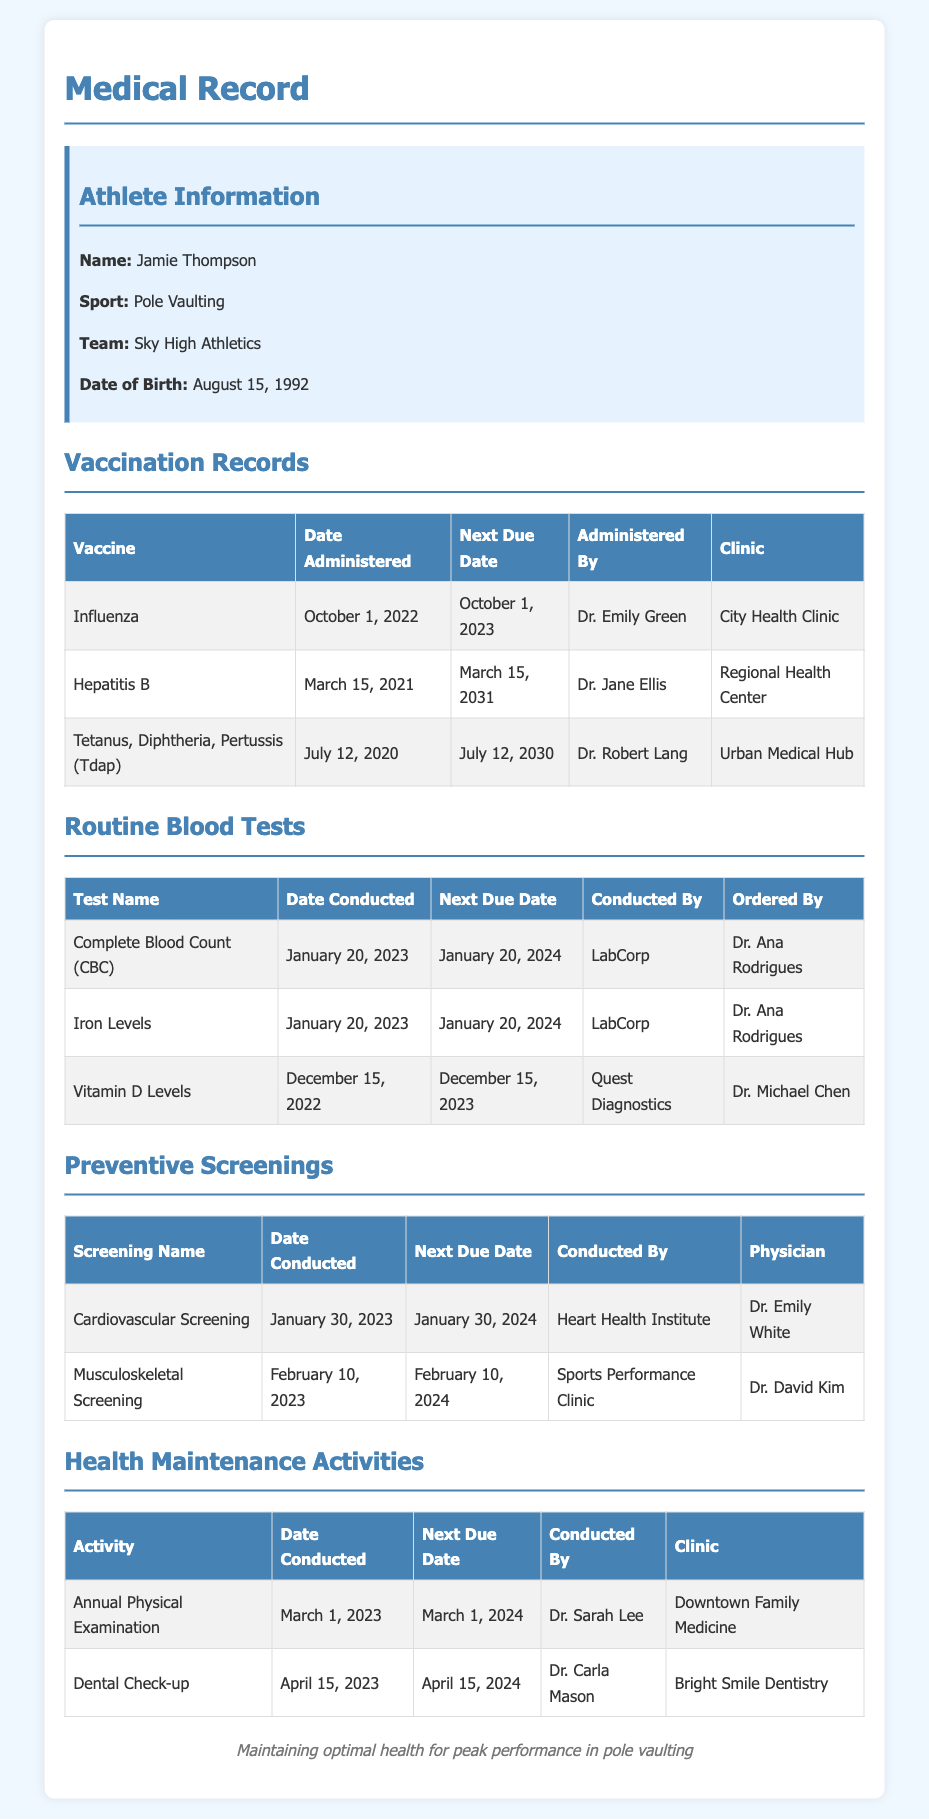What is the athlete's name? The athlete's name is listed in the document under "Athlete Information."
Answer: Jamie Thompson When was the last Influenza vaccine administered? The date of the last Influenza vaccine can be found in the Vaccination Records section.
Answer: October 1, 2022 What is the next due date for the Vitamin D Levels test? This information is found in the Routine Blood Tests table under the "Next Due Date" column for Vitamin D Levels.
Answer: December 15, 2023 Who conducted the Cardiovascular Screening? The name of the institute that conducted the Cardiovascular Screening is mentioned in the Preventive Screenings section.
Answer: Heart Health Institute How often should Jamie Thompson have an Annual Physical Examination? The date for the last examination is provided, which allows us to calculate the frequency based on the next due date.
Answer: Annually What is the date of the next Dental Check-up? The next due date is provided in the Health Maintenance Activities table for the Dental Check-up.
Answer: April 15, 2024 Which doctor administered the Tetanus, Diphtheria, Pertussis vaccine? The name of the doctor who administered the vaccine can be found in the Vaccination Records section.
Answer: Dr. Robert Lang How many preventive screenings were conducted in 2023? By counting the screening records listed in the Preventive Screenings section, we find out the total.
Answer: 2 What is the clinic for the Annual Physical Examination? The clinic name is mentioned in the Health Maintenance Activities section associated with the examination.
Answer: Downtown Family Medicine 